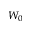Convert formula to latex. <formula><loc_0><loc_0><loc_500><loc_500>W _ { 0 }</formula> 